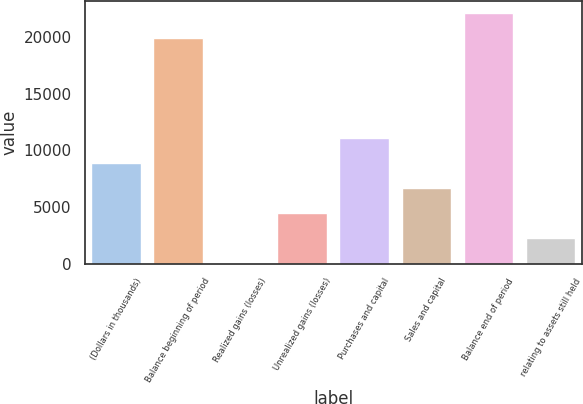Convert chart to OTSL. <chart><loc_0><loc_0><loc_500><loc_500><bar_chart><fcel>(Dollars in thousands)<fcel>Balance beginning of period<fcel>Realized gains (losses)<fcel>Unrealized gains (losses)<fcel>Purchases and capital<fcel>Sales and capital<fcel>Balance end of period<fcel>relating to assets still held<nl><fcel>8866.2<fcel>19921<fcel>75<fcel>4470.6<fcel>11064<fcel>6668.4<fcel>22118.8<fcel>2272.8<nl></chart> 